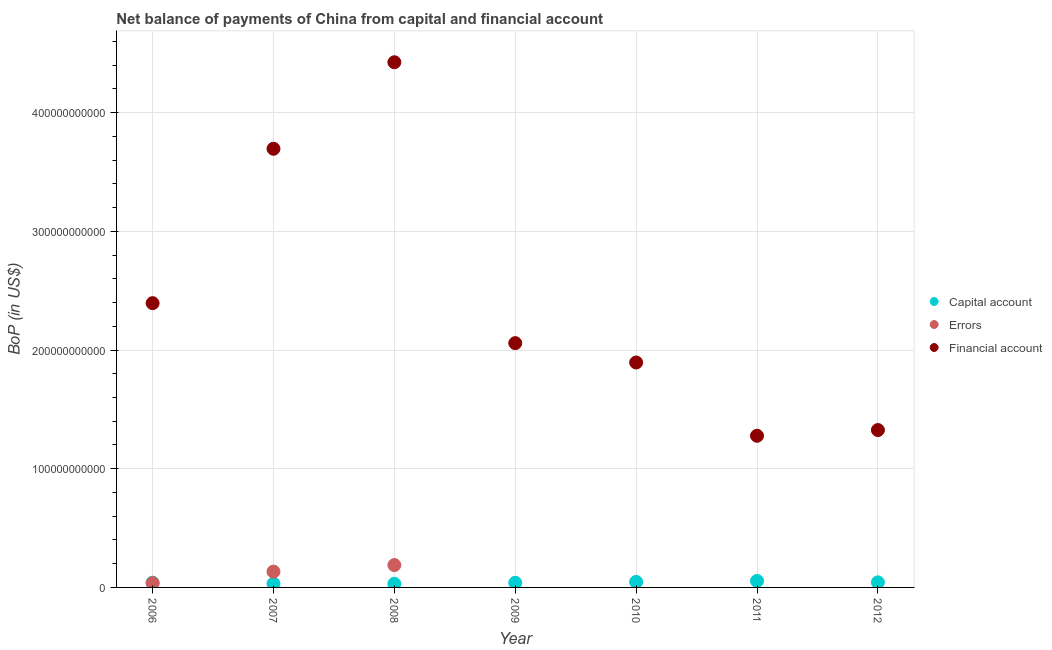Is the number of dotlines equal to the number of legend labels?
Your answer should be very brief. No. What is the amount of financial account in 2007?
Ensure brevity in your answer.  3.70e+11. Across all years, what is the maximum amount of errors?
Give a very brief answer. 1.88e+1. Across all years, what is the minimum amount of net capital account?
Keep it short and to the point. 3.05e+09. What is the total amount of errors in the graph?
Provide a short and direct response. 3.58e+1. What is the difference between the amount of net capital account in 2006 and that in 2007?
Offer a terse response. 9.21e+08. What is the difference between the amount of errors in 2006 and the amount of net capital account in 2009?
Your answer should be compact. -3.11e+08. What is the average amount of financial account per year?
Provide a short and direct response. 2.44e+11. In the year 2007, what is the difference between the amount of errors and amount of financial account?
Keep it short and to the point. -3.56e+11. In how many years, is the amount of net capital account greater than 200000000000 US$?
Provide a short and direct response. 0. What is the ratio of the amount of net capital account in 2007 to that in 2012?
Keep it short and to the point. 0.73. Is the amount of financial account in 2007 less than that in 2010?
Make the answer very short. No. What is the difference between the highest and the second highest amount of financial account?
Ensure brevity in your answer.  7.29e+1. What is the difference between the highest and the lowest amount of net capital account?
Your answer should be very brief. 2.39e+09. In how many years, is the amount of errors greater than the average amount of errors taken over all years?
Offer a very short reply. 2. Does the amount of financial account monotonically increase over the years?
Offer a terse response. No. Is the amount of errors strictly greater than the amount of financial account over the years?
Your answer should be compact. No. How many years are there in the graph?
Your answer should be compact. 7. What is the difference between two consecutive major ticks on the Y-axis?
Your response must be concise. 1.00e+11. Are the values on the major ticks of Y-axis written in scientific E-notation?
Provide a short and direct response. No. Does the graph contain grids?
Your response must be concise. Yes. How are the legend labels stacked?
Offer a very short reply. Vertical. What is the title of the graph?
Give a very brief answer. Net balance of payments of China from capital and financial account. Does "Communicable diseases" appear as one of the legend labels in the graph?
Offer a terse response. No. What is the label or title of the Y-axis?
Your answer should be compact. BoP (in US$). What is the BoP (in US$) in Capital account in 2006?
Your response must be concise. 4.02e+09. What is the BoP (in US$) in Errors in 2006?
Offer a terse response. 3.63e+09. What is the BoP (in US$) in Financial account in 2006?
Your answer should be very brief. 2.39e+11. What is the BoP (in US$) of Capital account in 2007?
Offer a terse response. 3.10e+09. What is the BoP (in US$) in Errors in 2007?
Offer a terse response. 1.33e+1. What is the BoP (in US$) of Financial account in 2007?
Offer a terse response. 3.70e+11. What is the BoP (in US$) of Capital account in 2008?
Provide a succinct answer. 3.05e+09. What is the BoP (in US$) of Errors in 2008?
Offer a terse response. 1.88e+1. What is the BoP (in US$) in Financial account in 2008?
Ensure brevity in your answer.  4.42e+11. What is the BoP (in US$) of Capital account in 2009?
Offer a terse response. 3.94e+09. What is the BoP (in US$) in Errors in 2009?
Ensure brevity in your answer.  0. What is the BoP (in US$) in Financial account in 2009?
Give a very brief answer. 2.06e+11. What is the BoP (in US$) in Capital account in 2010?
Provide a short and direct response. 4.63e+09. What is the BoP (in US$) of Financial account in 2010?
Provide a short and direct response. 1.90e+11. What is the BoP (in US$) in Capital account in 2011?
Your answer should be very brief. 5.45e+09. What is the BoP (in US$) in Financial account in 2011?
Offer a terse response. 1.28e+11. What is the BoP (in US$) of Capital account in 2012?
Provide a succinct answer. 4.27e+09. What is the BoP (in US$) of Errors in 2012?
Offer a very short reply. 0. What is the BoP (in US$) in Financial account in 2012?
Your answer should be compact. 1.33e+11. Across all years, what is the maximum BoP (in US$) of Capital account?
Provide a succinct answer. 5.45e+09. Across all years, what is the maximum BoP (in US$) in Errors?
Your response must be concise. 1.88e+1. Across all years, what is the maximum BoP (in US$) in Financial account?
Your answer should be compact. 4.42e+11. Across all years, what is the minimum BoP (in US$) in Capital account?
Your answer should be very brief. 3.05e+09. Across all years, what is the minimum BoP (in US$) in Errors?
Your answer should be very brief. 0. Across all years, what is the minimum BoP (in US$) of Financial account?
Offer a very short reply. 1.28e+11. What is the total BoP (in US$) in Capital account in the graph?
Ensure brevity in your answer.  2.85e+1. What is the total BoP (in US$) in Errors in the graph?
Ensure brevity in your answer.  3.58e+1. What is the total BoP (in US$) in Financial account in the graph?
Give a very brief answer. 1.71e+12. What is the difference between the BoP (in US$) of Capital account in 2006 and that in 2007?
Offer a very short reply. 9.21e+08. What is the difference between the BoP (in US$) in Errors in 2006 and that in 2007?
Ensure brevity in your answer.  -9.66e+09. What is the difference between the BoP (in US$) in Financial account in 2006 and that in 2007?
Offer a very short reply. -1.30e+11. What is the difference between the BoP (in US$) in Capital account in 2006 and that in 2008?
Your answer should be compact. 9.69e+08. What is the difference between the BoP (in US$) in Errors in 2006 and that in 2008?
Your response must be concise. -1.52e+1. What is the difference between the BoP (in US$) in Financial account in 2006 and that in 2008?
Make the answer very short. -2.03e+11. What is the difference between the BoP (in US$) in Capital account in 2006 and that in 2009?
Offer a very short reply. 8.08e+07. What is the difference between the BoP (in US$) of Financial account in 2006 and that in 2009?
Keep it short and to the point. 3.37e+1. What is the difference between the BoP (in US$) in Capital account in 2006 and that in 2010?
Offer a very short reply. -6.10e+08. What is the difference between the BoP (in US$) of Financial account in 2006 and that in 2010?
Provide a succinct answer. 5.00e+1. What is the difference between the BoP (in US$) in Capital account in 2006 and that in 2011?
Offer a terse response. -1.43e+09. What is the difference between the BoP (in US$) in Financial account in 2006 and that in 2011?
Provide a short and direct response. 1.12e+11. What is the difference between the BoP (in US$) in Capital account in 2006 and that in 2012?
Offer a very short reply. -2.52e+08. What is the difference between the BoP (in US$) of Financial account in 2006 and that in 2012?
Offer a terse response. 1.07e+11. What is the difference between the BoP (in US$) in Capital account in 2007 and that in 2008?
Give a very brief answer. 4.76e+07. What is the difference between the BoP (in US$) in Errors in 2007 and that in 2008?
Provide a succinct answer. -5.55e+09. What is the difference between the BoP (in US$) of Financial account in 2007 and that in 2008?
Provide a short and direct response. -7.29e+1. What is the difference between the BoP (in US$) in Capital account in 2007 and that in 2009?
Provide a succinct answer. -8.40e+08. What is the difference between the BoP (in US$) in Financial account in 2007 and that in 2009?
Offer a very short reply. 1.64e+11. What is the difference between the BoP (in US$) in Capital account in 2007 and that in 2010?
Your answer should be very brief. -1.53e+09. What is the difference between the BoP (in US$) in Financial account in 2007 and that in 2010?
Your response must be concise. 1.80e+11. What is the difference between the BoP (in US$) of Capital account in 2007 and that in 2011?
Your response must be concise. -2.35e+09. What is the difference between the BoP (in US$) in Financial account in 2007 and that in 2011?
Provide a succinct answer. 2.42e+11. What is the difference between the BoP (in US$) of Capital account in 2007 and that in 2012?
Your answer should be compact. -1.17e+09. What is the difference between the BoP (in US$) of Financial account in 2007 and that in 2012?
Offer a terse response. 2.37e+11. What is the difference between the BoP (in US$) of Capital account in 2008 and that in 2009?
Give a very brief answer. -8.88e+08. What is the difference between the BoP (in US$) in Financial account in 2008 and that in 2009?
Ensure brevity in your answer.  2.37e+11. What is the difference between the BoP (in US$) in Capital account in 2008 and that in 2010?
Give a very brief answer. -1.58e+09. What is the difference between the BoP (in US$) in Financial account in 2008 and that in 2010?
Your response must be concise. 2.53e+11. What is the difference between the BoP (in US$) of Capital account in 2008 and that in 2011?
Give a very brief answer. -2.39e+09. What is the difference between the BoP (in US$) of Financial account in 2008 and that in 2011?
Your answer should be compact. 3.15e+11. What is the difference between the BoP (in US$) of Capital account in 2008 and that in 2012?
Your answer should be very brief. -1.22e+09. What is the difference between the BoP (in US$) of Financial account in 2008 and that in 2012?
Your answer should be compact. 3.10e+11. What is the difference between the BoP (in US$) in Capital account in 2009 and that in 2010?
Your response must be concise. -6.91e+08. What is the difference between the BoP (in US$) in Financial account in 2009 and that in 2010?
Provide a succinct answer. 1.63e+1. What is the difference between the BoP (in US$) in Capital account in 2009 and that in 2011?
Ensure brevity in your answer.  -1.51e+09. What is the difference between the BoP (in US$) in Financial account in 2009 and that in 2011?
Ensure brevity in your answer.  7.80e+1. What is the difference between the BoP (in US$) of Capital account in 2009 and that in 2012?
Offer a very short reply. -3.33e+08. What is the difference between the BoP (in US$) of Financial account in 2009 and that in 2012?
Provide a succinct answer. 7.32e+1. What is the difference between the BoP (in US$) in Capital account in 2010 and that in 2011?
Offer a very short reply. -8.16e+08. What is the difference between the BoP (in US$) of Financial account in 2010 and that in 2011?
Your answer should be compact. 6.17e+1. What is the difference between the BoP (in US$) in Capital account in 2010 and that in 2012?
Provide a succinct answer. 3.58e+08. What is the difference between the BoP (in US$) of Financial account in 2010 and that in 2012?
Your answer should be compact. 5.69e+1. What is the difference between the BoP (in US$) in Capital account in 2011 and that in 2012?
Your response must be concise. 1.17e+09. What is the difference between the BoP (in US$) in Financial account in 2011 and that in 2012?
Your answer should be compact. -4.81e+09. What is the difference between the BoP (in US$) of Capital account in 2006 and the BoP (in US$) of Errors in 2007?
Your answer should be compact. -9.27e+09. What is the difference between the BoP (in US$) in Capital account in 2006 and the BoP (in US$) in Financial account in 2007?
Your answer should be compact. -3.66e+11. What is the difference between the BoP (in US$) in Errors in 2006 and the BoP (in US$) in Financial account in 2007?
Provide a succinct answer. -3.66e+11. What is the difference between the BoP (in US$) in Capital account in 2006 and the BoP (in US$) in Errors in 2008?
Offer a very short reply. -1.48e+1. What is the difference between the BoP (in US$) in Capital account in 2006 and the BoP (in US$) in Financial account in 2008?
Provide a short and direct response. -4.38e+11. What is the difference between the BoP (in US$) of Errors in 2006 and the BoP (in US$) of Financial account in 2008?
Offer a terse response. -4.39e+11. What is the difference between the BoP (in US$) in Capital account in 2006 and the BoP (in US$) in Financial account in 2009?
Make the answer very short. -2.02e+11. What is the difference between the BoP (in US$) of Errors in 2006 and the BoP (in US$) of Financial account in 2009?
Provide a succinct answer. -2.02e+11. What is the difference between the BoP (in US$) of Capital account in 2006 and the BoP (in US$) of Financial account in 2010?
Provide a short and direct response. -1.85e+11. What is the difference between the BoP (in US$) of Errors in 2006 and the BoP (in US$) of Financial account in 2010?
Your answer should be very brief. -1.86e+11. What is the difference between the BoP (in US$) of Capital account in 2006 and the BoP (in US$) of Financial account in 2011?
Your answer should be very brief. -1.24e+11. What is the difference between the BoP (in US$) in Errors in 2006 and the BoP (in US$) in Financial account in 2011?
Your answer should be very brief. -1.24e+11. What is the difference between the BoP (in US$) of Capital account in 2006 and the BoP (in US$) of Financial account in 2012?
Your answer should be compact. -1.29e+11. What is the difference between the BoP (in US$) of Errors in 2006 and the BoP (in US$) of Financial account in 2012?
Keep it short and to the point. -1.29e+11. What is the difference between the BoP (in US$) of Capital account in 2007 and the BoP (in US$) of Errors in 2008?
Your answer should be very brief. -1.57e+1. What is the difference between the BoP (in US$) in Capital account in 2007 and the BoP (in US$) in Financial account in 2008?
Provide a succinct answer. -4.39e+11. What is the difference between the BoP (in US$) in Errors in 2007 and the BoP (in US$) in Financial account in 2008?
Give a very brief answer. -4.29e+11. What is the difference between the BoP (in US$) of Capital account in 2007 and the BoP (in US$) of Financial account in 2009?
Make the answer very short. -2.03e+11. What is the difference between the BoP (in US$) of Errors in 2007 and the BoP (in US$) of Financial account in 2009?
Make the answer very short. -1.93e+11. What is the difference between the BoP (in US$) in Capital account in 2007 and the BoP (in US$) in Financial account in 2010?
Provide a short and direct response. -1.86e+11. What is the difference between the BoP (in US$) in Errors in 2007 and the BoP (in US$) in Financial account in 2010?
Your answer should be compact. -1.76e+11. What is the difference between the BoP (in US$) in Capital account in 2007 and the BoP (in US$) in Financial account in 2011?
Give a very brief answer. -1.25e+11. What is the difference between the BoP (in US$) of Errors in 2007 and the BoP (in US$) of Financial account in 2011?
Offer a very short reply. -1.14e+11. What is the difference between the BoP (in US$) in Capital account in 2007 and the BoP (in US$) in Financial account in 2012?
Make the answer very short. -1.29e+11. What is the difference between the BoP (in US$) in Errors in 2007 and the BoP (in US$) in Financial account in 2012?
Provide a short and direct response. -1.19e+11. What is the difference between the BoP (in US$) of Capital account in 2008 and the BoP (in US$) of Financial account in 2009?
Offer a terse response. -2.03e+11. What is the difference between the BoP (in US$) in Errors in 2008 and the BoP (in US$) in Financial account in 2009?
Offer a terse response. -1.87e+11. What is the difference between the BoP (in US$) in Capital account in 2008 and the BoP (in US$) in Financial account in 2010?
Keep it short and to the point. -1.86e+11. What is the difference between the BoP (in US$) of Errors in 2008 and the BoP (in US$) of Financial account in 2010?
Ensure brevity in your answer.  -1.71e+11. What is the difference between the BoP (in US$) of Capital account in 2008 and the BoP (in US$) of Financial account in 2011?
Your response must be concise. -1.25e+11. What is the difference between the BoP (in US$) of Errors in 2008 and the BoP (in US$) of Financial account in 2011?
Your response must be concise. -1.09e+11. What is the difference between the BoP (in US$) in Capital account in 2008 and the BoP (in US$) in Financial account in 2012?
Your response must be concise. -1.30e+11. What is the difference between the BoP (in US$) of Errors in 2008 and the BoP (in US$) of Financial account in 2012?
Offer a very short reply. -1.14e+11. What is the difference between the BoP (in US$) in Capital account in 2009 and the BoP (in US$) in Financial account in 2010?
Offer a terse response. -1.86e+11. What is the difference between the BoP (in US$) in Capital account in 2009 and the BoP (in US$) in Financial account in 2011?
Offer a terse response. -1.24e+11. What is the difference between the BoP (in US$) of Capital account in 2009 and the BoP (in US$) of Financial account in 2012?
Offer a terse response. -1.29e+11. What is the difference between the BoP (in US$) in Capital account in 2010 and the BoP (in US$) in Financial account in 2011?
Provide a succinct answer. -1.23e+11. What is the difference between the BoP (in US$) in Capital account in 2010 and the BoP (in US$) in Financial account in 2012?
Your answer should be compact. -1.28e+11. What is the difference between the BoP (in US$) in Capital account in 2011 and the BoP (in US$) in Financial account in 2012?
Your answer should be compact. -1.27e+11. What is the average BoP (in US$) of Capital account per year?
Offer a very short reply. 4.07e+09. What is the average BoP (in US$) of Errors per year?
Offer a terse response. 5.11e+09. What is the average BoP (in US$) of Financial account per year?
Provide a short and direct response. 2.44e+11. In the year 2006, what is the difference between the BoP (in US$) of Capital account and BoP (in US$) of Errors?
Provide a succinct answer. 3.92e+08. In the year 2006, what is the difference between the BoP (in US$) in Capital account and BoP (in US$) in Financial account?
Give a very brief answer. -2.35e+11. In the year 2006, what is the difference between the BoP (in US$) of Errors and BoP (in US$) of Financial account?
Offer a terse response. -2.36e+11. In the year 2007, what is the difference between the BoP (in US$) in Capital account and BoP (in US$) in Errors?
Make the answer very short. -1.02e+1. In the year 2007, what is the difference between the BoP (in US$) in Capital account and BoP (in US$) in Financial account?
Your answer should be compact. -3.66e+11. In the year 2007, what is the difference between the BoP (in US$) in Errors and BoP (in US$) in Financial account?
Your response must be concise. -3.56e+11. In the year 2008, what is the difference between the BoP (in US$) in Capital account and BoP (in US$) in Errors?
Your response must be concise. -1.58e+1. In the year 2008, what is the difference between the BoP (in US$) in Capital account and BoP (in US$) in Financial account?
Your answer should be very brief. -4.39e+11. In the year 2008, what is the difference between the BoP (in US$) in Errors and BoP (in US$) in Financial account?
Offer a very short reply. -4.24e+11. In the year 2009, what is the difference between the BoP (in US$) of Capital account and BoP (in US$) of Financial account?
Offer a very short reply. -2.02e+11. In the year 2010, what is the difference between the BoP (in US$) of Capital account and BoP (in US$) of Financial account?
Offer a terse response. -1.85e+11. In the year 2011, what is the difference between the BoP (in US$) in Capital account and BoP (in US$) in Financial account?
Give a very brief answer. -1.22e+11. In the year 2012, what is the difference between the BoP (in US$) in Capital account and BoP (in US$) in Financial account?
Provide a short and direct response. -1.28e+11. What is the ratio of the BoP (in US$) in Capital account in 2006 to that in 2007?
Provide a short and direct response. 1.3. What is the ratio of the BoP (in US$) of Errors in 2006 to that in 2007?
Keep it short and to the point. 0.27. What is the ratio of the BoP (in US$) in Financial account in 2006 to that in 2007?
Offer a very short reply. 0.65. What is the ratio of the BoP (in US$) of Capital account in 2006 to that in 2008?
Ensure brevity in your answer.  1.32. What is the ratio of the BoP (in US$) in Errors in 2006 to that in 2008?
Ensure brevity in your answer.  0.19. What is the ratio of the BoP (in US$) of Financial account in 2006 to that in 2008?
Your response must be concise. 0.54. What is the ratio of the BoP (in US$) in Capital account in 2006 to that in 2009?
Offer a terse response. 1.02. What is the ratio of the BoP (in US$) of Financial account in 2006 to that in 2009?
Your response must be concise. 1.16. What is the ratio of the BoP (in US$) in Capital account in 2006 to that in 2010?
Make the answer very short. 0.87. What is the ratio of the BoP (in US$) in Financial account in 2006 to that in 2010?
Your response must be concise. 1.26. What is the ratio of the BoP (in US$) in Capital account in 2006 to that in 2011?
Provide a short and direct response. 0.74. What is the ratio of the BoP (in US$) of Financial account in 2006 to that in 2011?
Keep it short and to the point. 1.87. What is the ratio of the BoP (in US$) in Capital account in 2006 to that in 2012?
Keep it short and to the point. 0.94. What is the ratio of the BoP (in US$) in Financial account in 2006 to that in 2012?
Your answer should be compact. 1.81. What is the ratio of the BoP (in US$) of Capital account in 2007 to that in 2008?
Offer a very short reply. 1.02. What is the ratio of the BoP (in US$) in Errors in 2007 to that in 2008?
Make the answer very short. 0.71. What is the ratio of the BoP (in US$) of Financial account in 2007 to that in 2008?
Your answer should be compact. 0.84. What is the ratio of the BoP (in US$) in Capital account in 2007 to that in 2009?
Keep it short and to the point. 0.79. What is the ratio of the BoP (in US$) of Financial account in 2007 to that in 2009?
Offer a very short reply. 1.8. What is the ratio of the BoP (in US$) of Capital account in 2007 to that in 2010?
Offer a very short reply. 0.67. What is the ratio of the BoP (in US$) in Financial account in 2007 to that in 2010?
Offer a very short reply. 1.95. What is the ratio of the BoP (in US$) of Capital account in 2007 to that in 2011?
Your answer should be compact. 0.57. What is the ratio of the BoP (in US$) in Financial account in 2007 to that in 2011?
Offer a terse response. 2.89. What is the ratio of the BoP (in US$) of Capital account in 2007 to that in 2012?
Make the answer very short. 0.73. What is the ratio of the BoP (in US$) in Financial account in 2007 to that in 2012?
Offer a terse response. 2.79. What is the ratio of the BoP (in US$) in Capital account in 2008 to that in 2009?
Offer a very short reply. 0.77. What is the ratio of the BoP (in US$) of Financial account in 2008 to that in 2009?
Offer a very short reply. 2.15. What is the ratio of the BoP (in US$) of Capital account in 2008 to that in 2010?
Offer a very short reply. 0.66. What is the ratio of the BoP (in US$) in Financial account in 2008 to that in 2010?
Provide a succinct answer. 2.33. What is the ratio of the BoP (in US$) in Capital account in 2008 to that in 2011?
Keep it short and to the point. 0.56. What is the ratio of the BoP (in US$) in Financial account in 2008 to that in 2011?
Give a very brief answer. 3.46. What is the ratio of the BoP (in US$) of Capital account in 2008 to that in 2012?
Offer a very short reply. 0.71. What is the ratio of the BoP (in US$) in Financial account in 2008 to that in 2012?
Offer a very short reply. 3.34. What is the ratio of the BoP (in US$) of Capital account in 2009 to that in 2010?
Ensure brevity in your answer.  0.85. What is the ratio of the BoP (in US$) in Financial account in 2009 to that in 2010?
Make the answer very short. 1.09. What is the ratio of the BoP (in US$) of Capital account in 2009 to that in 2011?
Your response must be concise. 0.72. What is the ratio of the BoP (in US$) of Financial account in 2009 to that in 2011?
Your answer should be compact. 1.61. What is the ratio of the BoP (in US$) in Capital account in 2009 to that in 2012?
Offer a terse response. 0.92. What is the ratio of the BoP (in US$) of Financial account in 2009 to that in 2012?
Give a very brief answer. 1.55. What is the ratio of the BoP (in US$) in Capital account in 2010 to that in 2011?
Make the answer very short. 0.85. What is the ratio of the BoP (in US$) of Financial account in 2010 to that in 2011?
Provide a succinct answer. 1.48. What is the ratio of the BoP (in US$) of Capital account in 2010 to that in 2012?
Give a very brief answer. 1.08. What is the ratio of the BoP (in US$) of Financial account in 2010 to that in 2012?
Provide a succinct answer. 1.43. What is the ratio of the BoP (in US$) of Capital account in 2011 to that in 2012?
Your answer should be very brief. 1.27. What is the ratio of the BoP (in US$) of Financial account in 2011 to that in 2012?
Your answer should be compact. 0.96. What is the difference between the highest and the second highest BoP (in US$) of Capital account?
Give a very brief answer. 8.16e+08. What is the difference between the highest and the second highest BoP (in US$) in Errors?
Provide a short and direct response. 5.55e+09. What is the difference between the highest and the second highest BoP (in US$) of Financial account?
Offer a terse response. 7.29e+1. What is the difference between the highest and the lowest BoP (in US$) of Capital account?
Keep it short and to the point. 2.39e+09. What is the difference between the highest and the lowest BoP (in US$) in Errors?
Provide a short and direct response. 1.88e+1. What is the difference between the highest and the lowest BoP (in US$) of Financial account?
Offer a very short reply. 3.15e+11. 